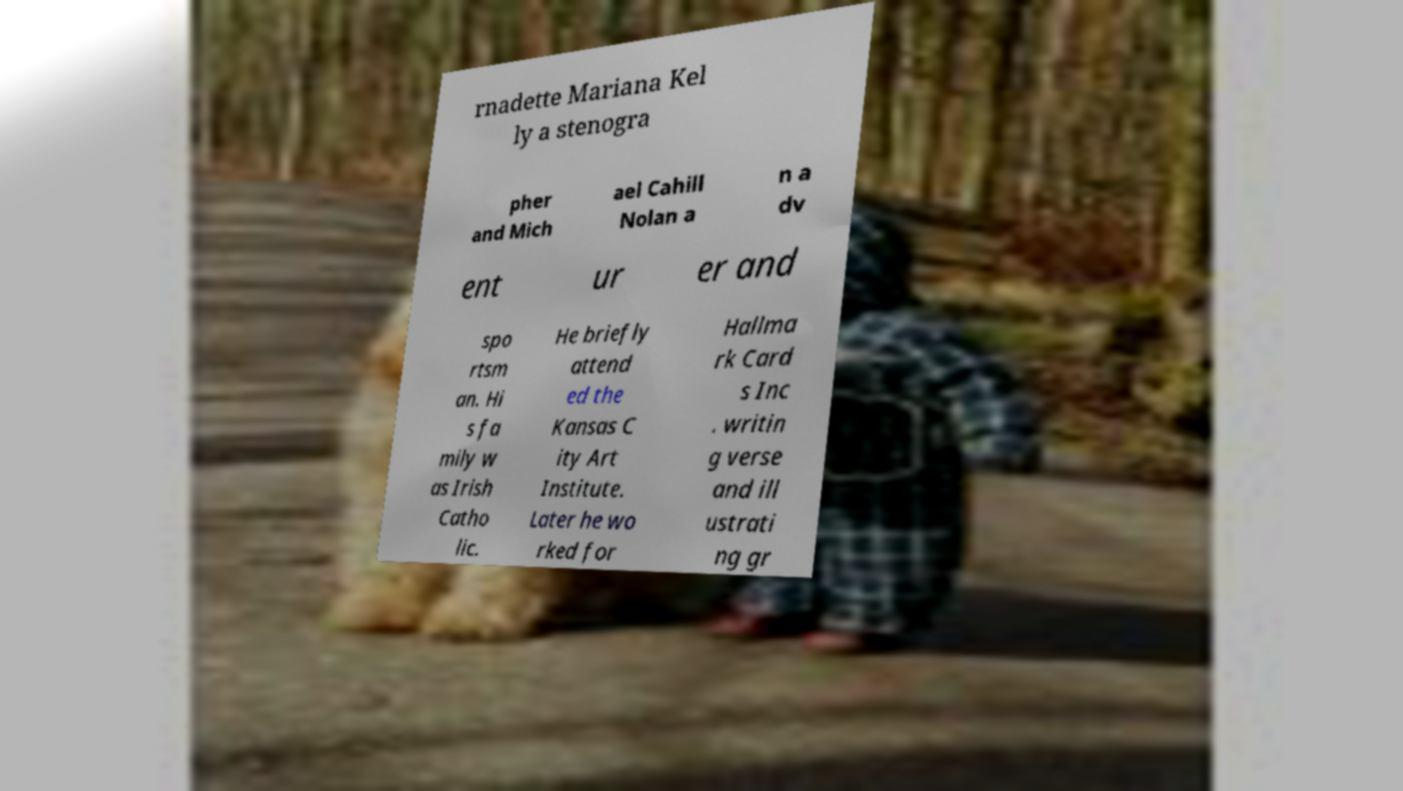Could you assist in decoding the text presented in this image and type it out clearly? rnadette Mariana Kel ly a stenogra pher and Mich ael Cahill Nolan a n a dv ent ur er and spo rtsm an. Hi s fa mily w as Irish Catho lic. He briefly attend ed the Kansas C ity Art Institute. Later he wo rked for Hallma rk Card s Inc . writin g verse and ill ustrati ng gr 